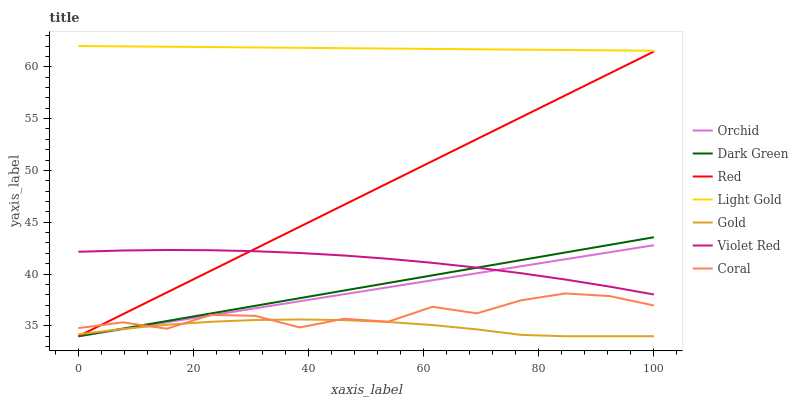Does Coral have the minimum area under the curve?
Answer yes or no. No. Does Coral have the maximum area under the curve?
Answer yes or no. No. Is Gold the smoothest?
Answer yes or no. No. Is Gold the roughest?
Answer yes or no. No. Does Coral have the lowest value?
Answer yes or no. No. Does Coral have the highest value?
Answer yes or no. No. Is Gold less than Light Gold?
Answer yes or no. Yes. Is Violet Red greater than Gold?
Answer yes or no. Yes. Does Gold intersect Light Gold?
Answer yes or no. No. 